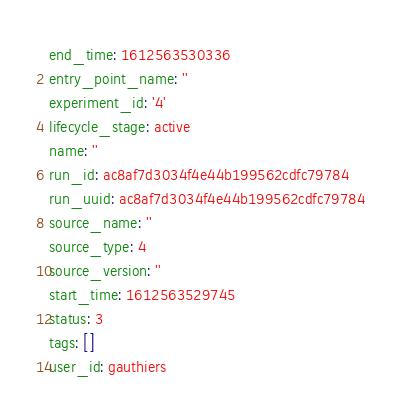Convert code to text. <code><loc_0><loc_0><loc_500><loc_500><_YAML_>end_time: 1612563530336
entry_point_name: ''
experiment_id: '4'
lifecycle_stage: active
name: ''
run_id: ac8af7d3034f4e44b199562cdfc79784
run_uuid: ac8af7d3034f4e44b199562cdfc79784
source_name: ''
source_type: 4
source_version: ''
start_time: 1612563529745
status: 3
tags: []
user_id: gauthiers
</code> 